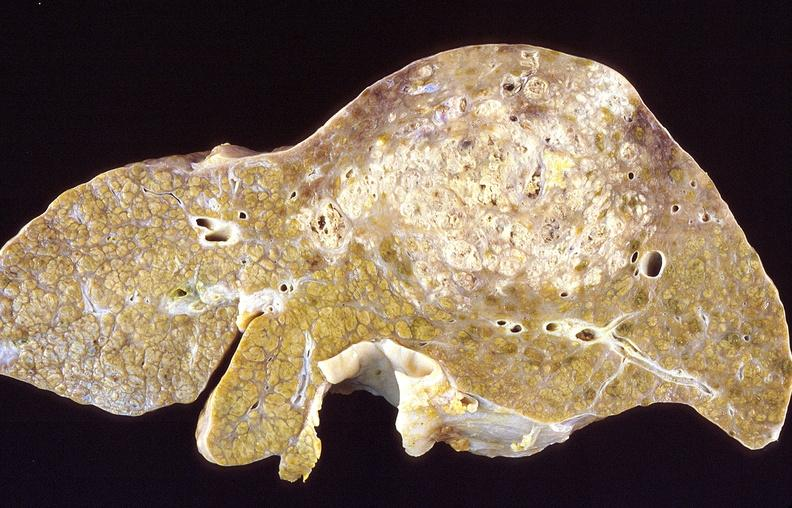s liver present?
Answer the question using a single word or phrase. Yes 